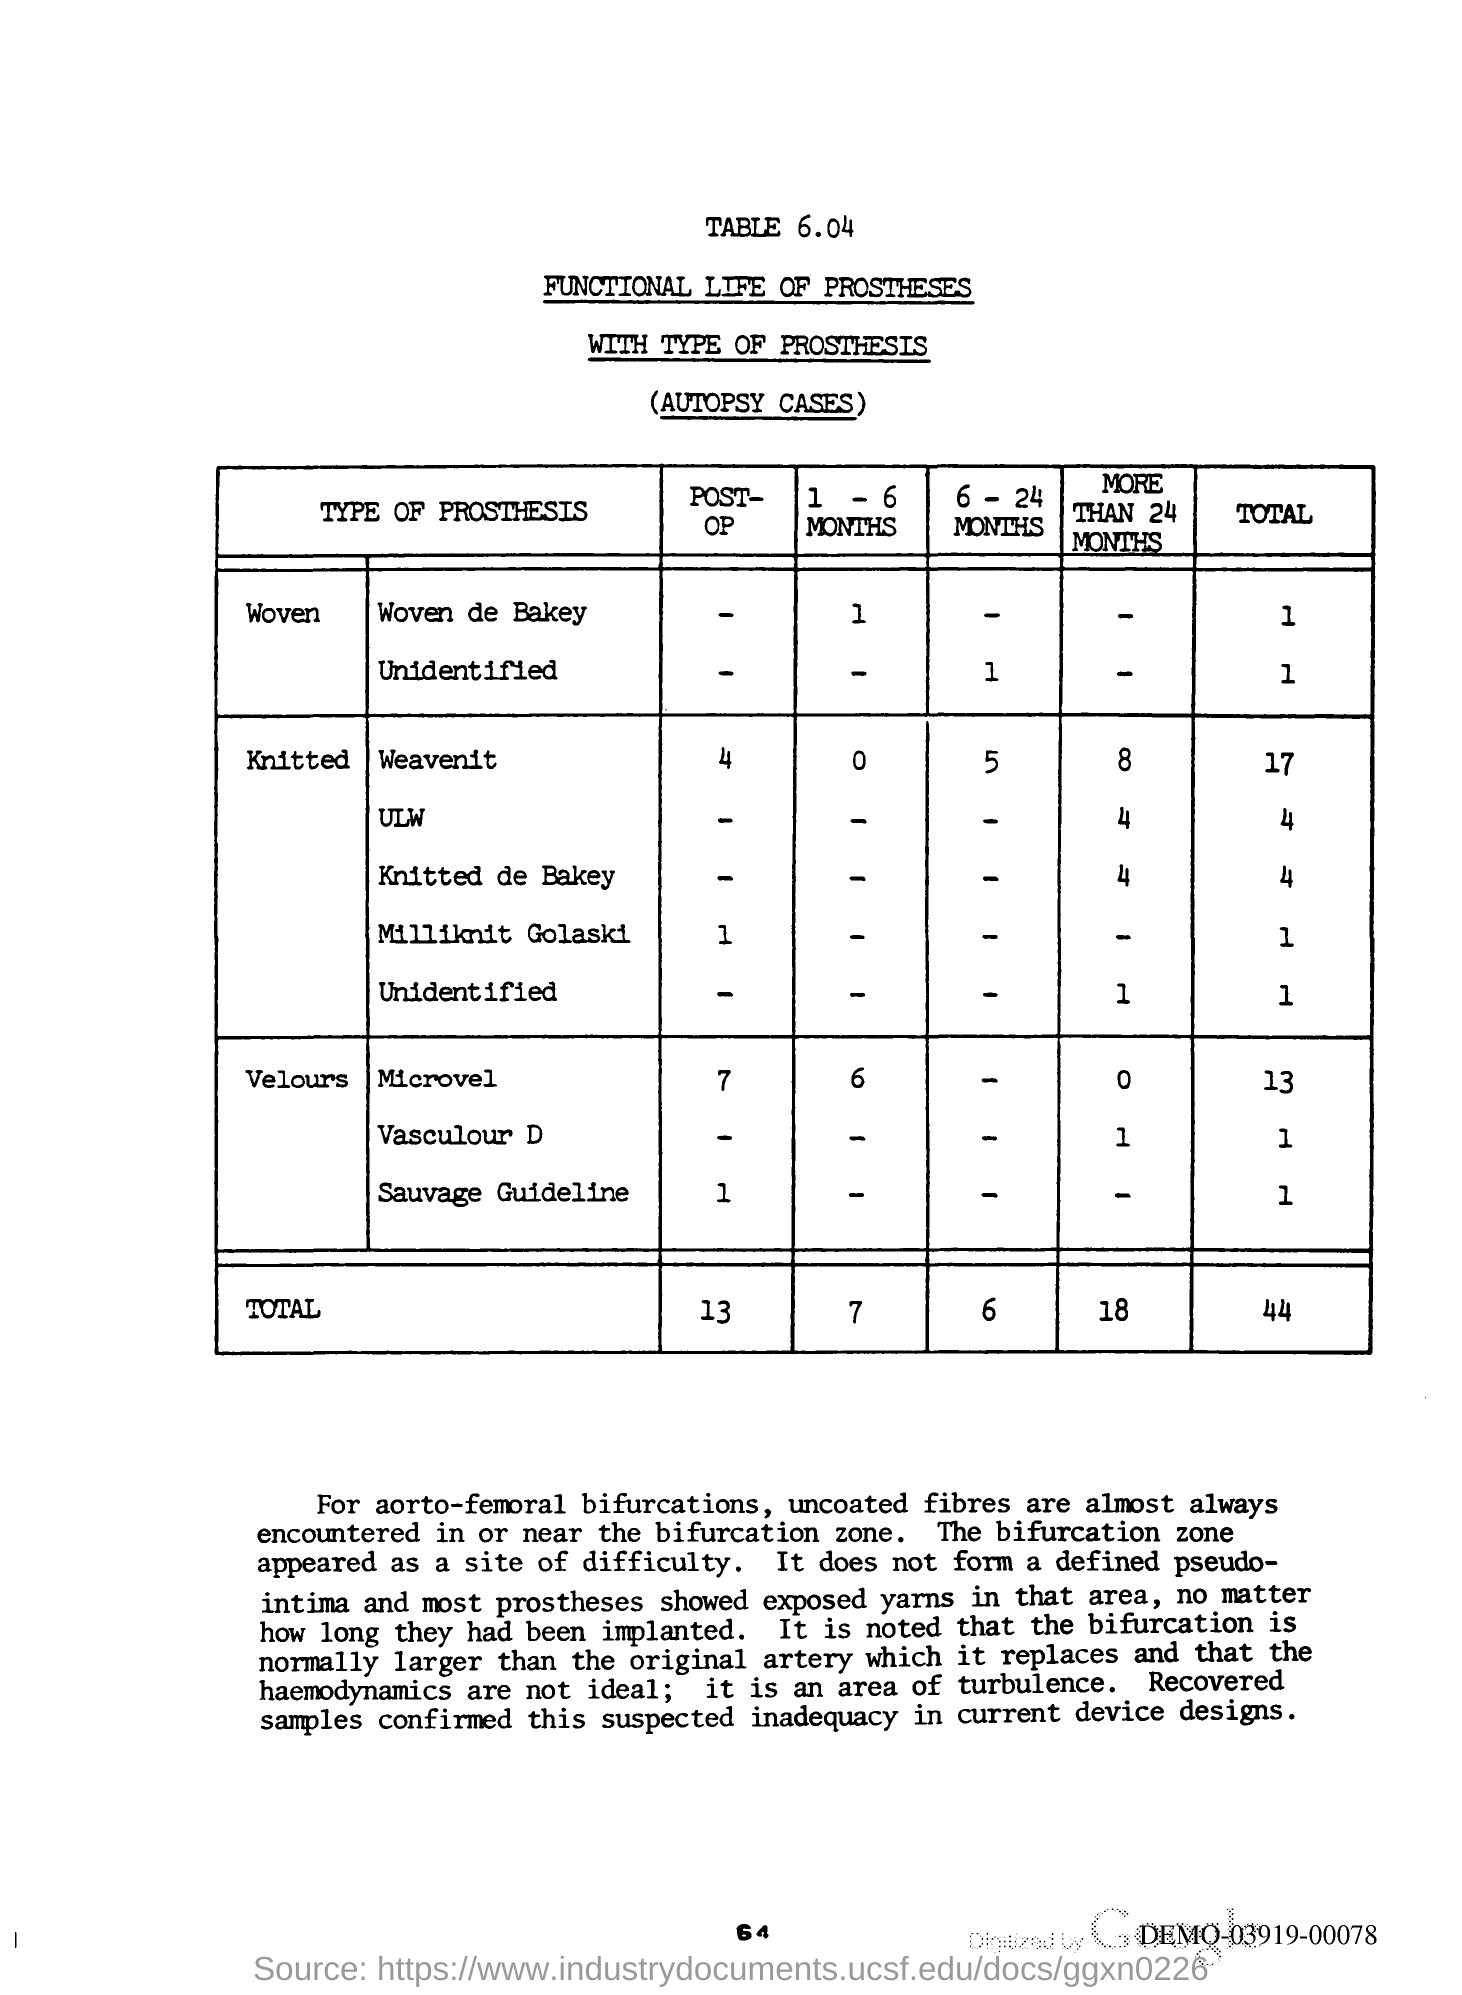Outline some significant characteristics in this image. The total post-op is 13. 